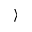Convert formula to latex. <formula><loc_0><loc_0><loc_500><loc_500>\rangle</formula> 